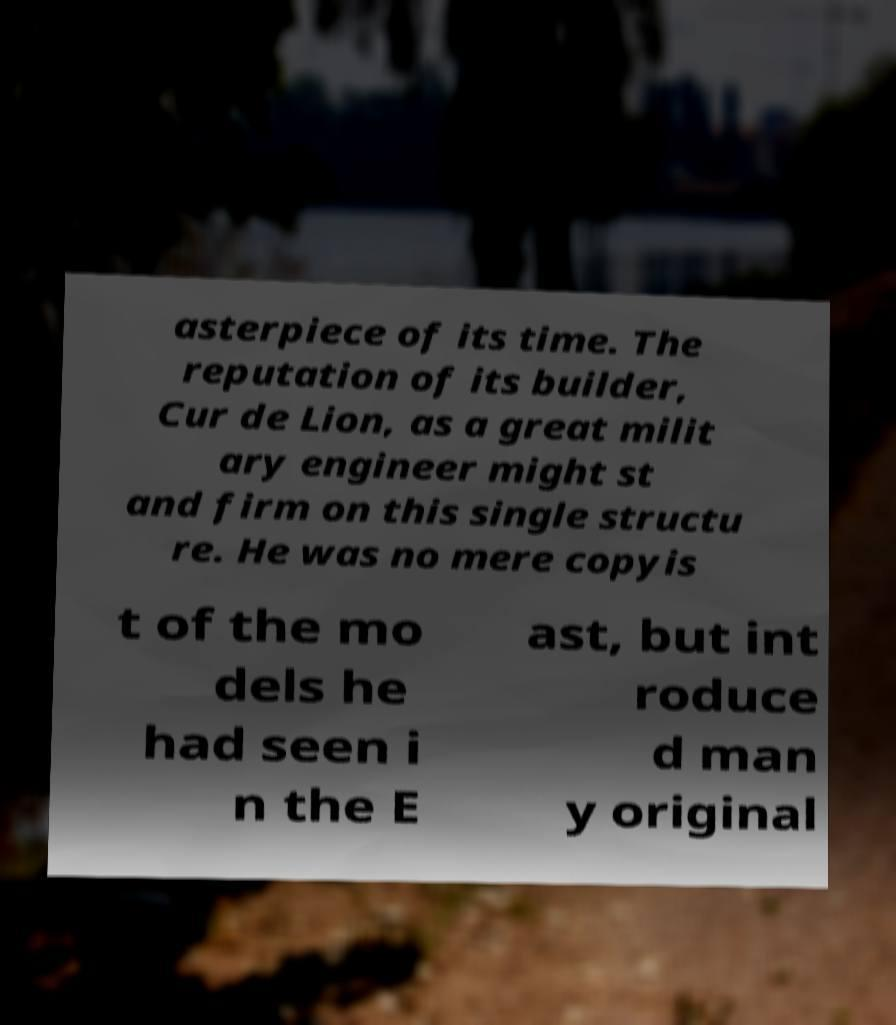Can you accurately transcribe the text from the provided image for me? asterpiece of its time. The reputation of its builder, Cur de Lion, as a great milit ary engineer might st and firm on this single structu re. He was no mere copyis t of the mo dels he had seen i n the E ast, but int roduce d man y original 